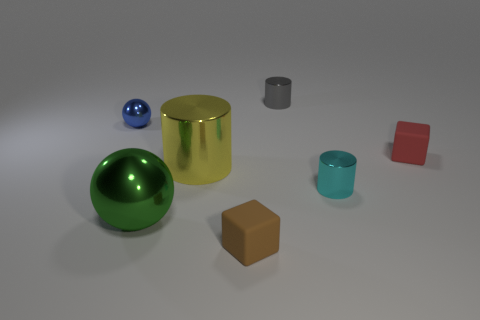Is the green ball the same size as the blue one? From the perspective provided in the image, the green ball seems slightly larger than the blue one, though without a scale, it's hard to determine their exact sizes. 